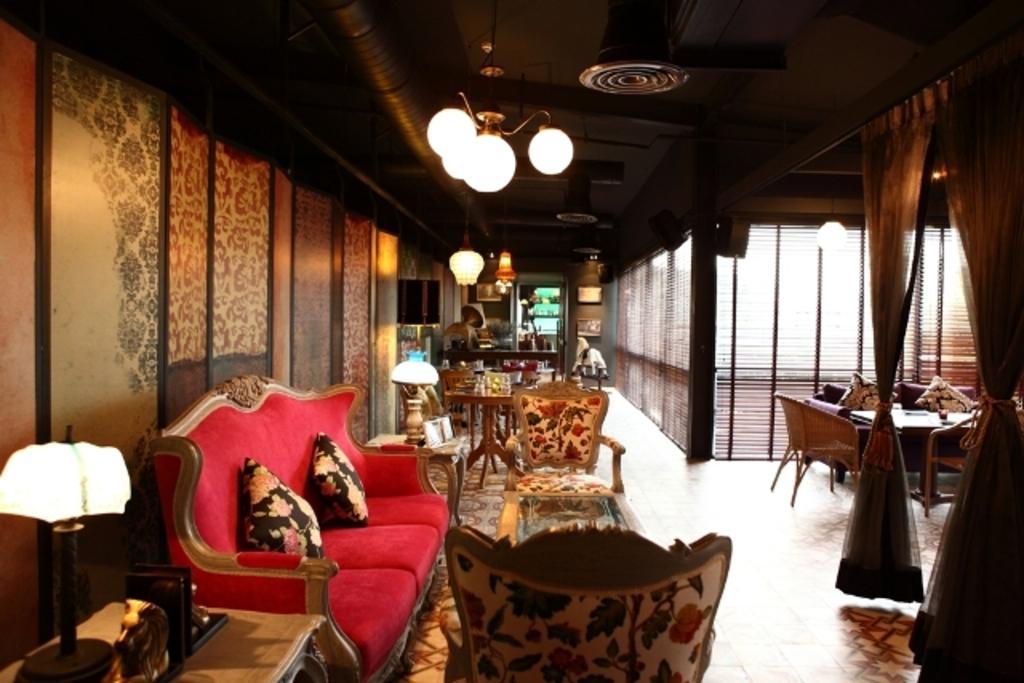Please provide a concise description of this image. This is an inside view of a building and here we can see chairs, sofas, cushions, tables, lights, stands and some objects, curtains, frames and some other objects. At the top, there is roof and at the bottom, there is floor. 